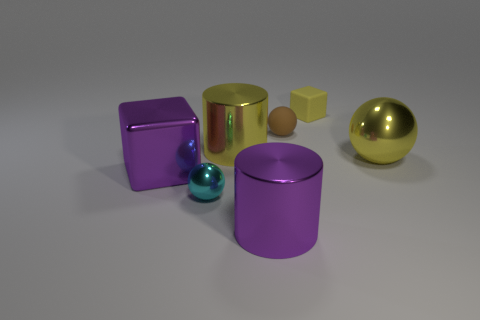Subtract all brown blocks. Subtract all cyan cylinders. How many blocks are left? 2 Add 3 small cyan shiny spheres. How many objects exist? 10 Subtract all cylinders. How many objects are left? 5 Subtract 0 gray blocks. How many objects are left? 7 Subtract all small gray rubber things. Subtract all purple metal cylinders. How many objects are left? 6 Add 7 small objects. How many small objects are left? 10 Add 1 yellow spheres. How many yellow spheres exist? 2 